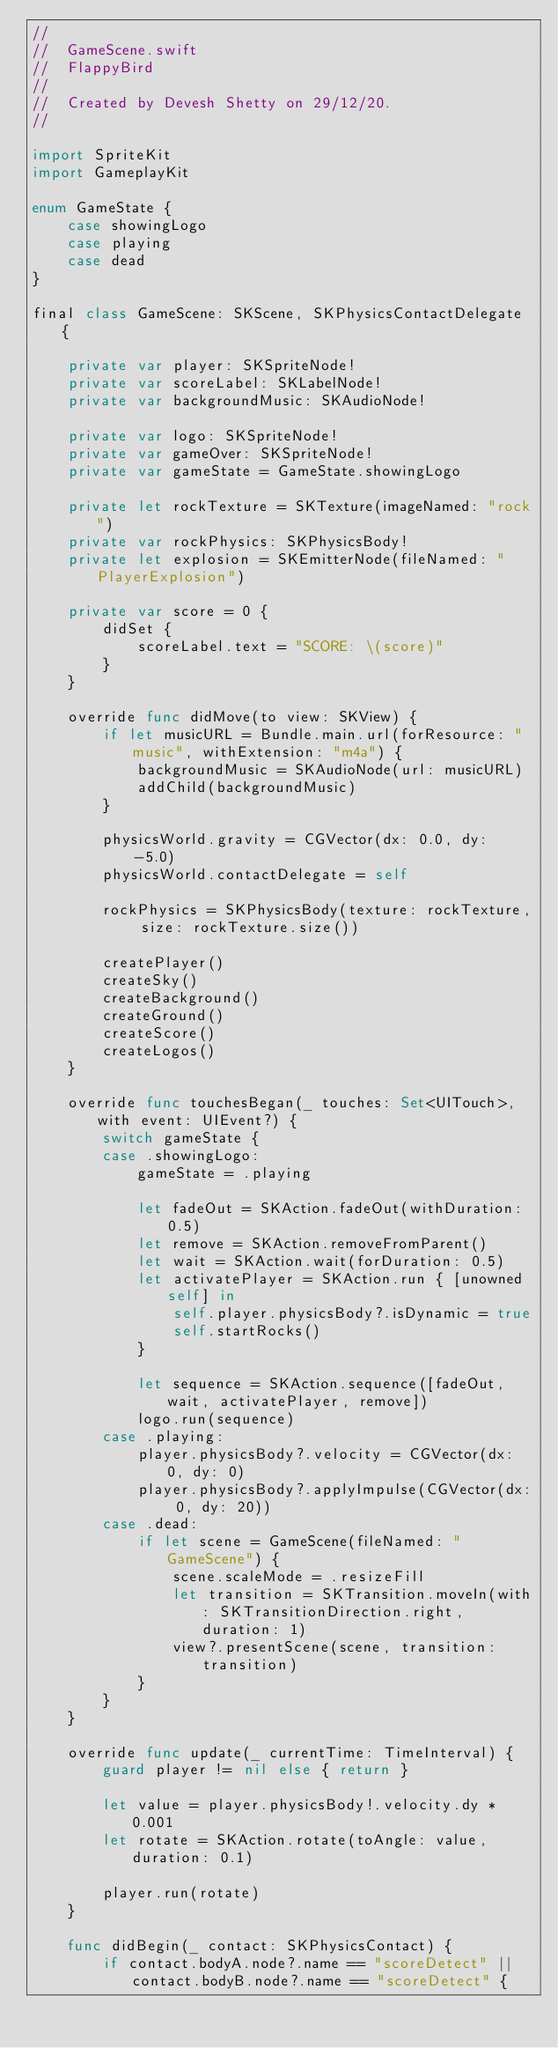<code> <loc_0><loc_0><loc_500><loc_500><_Swift_>//
//  GameScene.swift
//  FlappyBird
//
//  Created by Devesh Shetty on 29/12/20.
//

import SpriteKit
import GameplayKit

enum GameState {
    case showingLogo
    case playing
    case dead
}

final class GameScene: SKScene, SKPhysicsContactDelegate {
    
    private var player: SKSpriteNode!
    private var scoreLabel: SKLabelNode!
    private var backgroundMusic: SKAudioNode!
    
    private var logo: SKSpriteNode!
    private var gameOver: SKSpriteNode!
    private var gameState = GameState.showingLogo
    
    private let rockTexture = SKTexture(imageNamed: "rock")
    private var rockPhysics: SKPhysicsBody!
    private let explosion = SKEmitterNode(fileNamed: "PlayerExplosion")
    
    private var score = 0 {
        didSet {
            scoreLabel.text = "SCORE: \(score)"
        }
    }
    
    override func didMove(to view: SKView) {
        if let musicURL = Bundle.main.url(forResource: "music", withExtension: "m4a") {
            backgroundMusic = SKAudioNode(url: musicURL)
            addChild(backgroundMusic)
        }
        
        physicsWorld.gravity = CGVector(dx: 0.0, dy: -5.0)
        physicsWorld.contactDelegate = self
        
        rockPhysics = SKPhysicsBody(texture: rockTexture, size: rockTexture.size())
        
        createPlayer()
        createSky()
        createBackground()
        createGround()
        createScore()
        createLogos()
    }
    
    override func touchesBegan(_ touches: Set<UITouch>, with event: UIEvent?) {
        switch gameState {
        case .showingLogo:
            gameState = .playing
            
            let fadeOut = SKAction.fadeOut(withDuration: 0.5)
            let remove = SKAction.removeFromParent()
            let wait = SKAction.wait(forDuration: 0.5)
            let activatePlayer = SKAction.run { [unowned self] in
                self.player.physicsBody?.isDynamic = true
                self.startRocks()
            }
            
            let sequence = SKAction.sequence([fadeOut, wait, activatePlayer, remove])
            logo.run(sequence)
        case .playing:
            player.physicsBody?.velocity = CGVector(dx: 0, dy: 0)
            player.physicsBody?.applyImpulse(CGVector(dx: 0, dy: 20))
        case .dead:
            if let scene = GameScene(fileNamed: "GameScene") {
                scene.scaleMode = .resizeFill
                let transition = SKTransition.moveIn(with: SKTransitionDirection.right, duration: 1)
                view?.presentScene(scene, transition: transition)
            }
        }
    }
    
    override func update(_ currentTime: TimeInterval) {
        guard player != nil else { return }
        
        let value = player.physicsBody!.velocity.dy * 0.001
        let rotate = SKAction.rotate(toAngle: value, duration: 0.1)
        
        player.run(rotate)
    }
    
    func didBegin(_ contact: SKPhysicsContact) {
        if contact.bodyA.node?.name == "scoreDetect" || contact.bodyB.node?.name == "scoreDetect" {</code> 